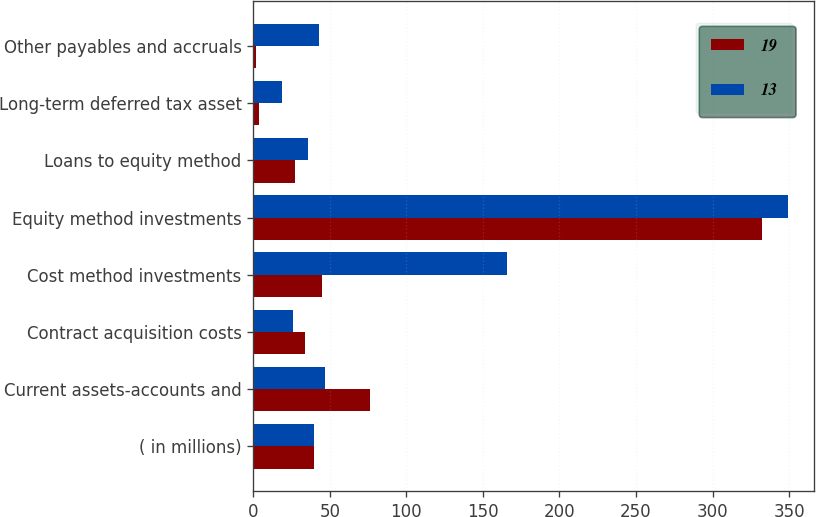<chart> <loc_0><loc_0><loc_500><loc_500><stacked_bar_chart><ecel><fcel>( in millions)<fcel>Current assets-accounts and<fcel>Contract acquisition costs<fcel>Cost method investments<fcel>Equity method investments<fcel>Loans to equity method<fcel>Long-term deferred tax asset<fcel>Other payables and accruals<nl><fcel>19<fcel>39.5<fcel>76<fcel>34<fcel>45<fcel>332<fcel>27<fcel>4<fcel>2<nl><fcel>13<fcel>39.5<fcel>47<fcel>26<fcel>166<fcel>349<fcel>36<fcel>19<fcel>43<nl></chart> 